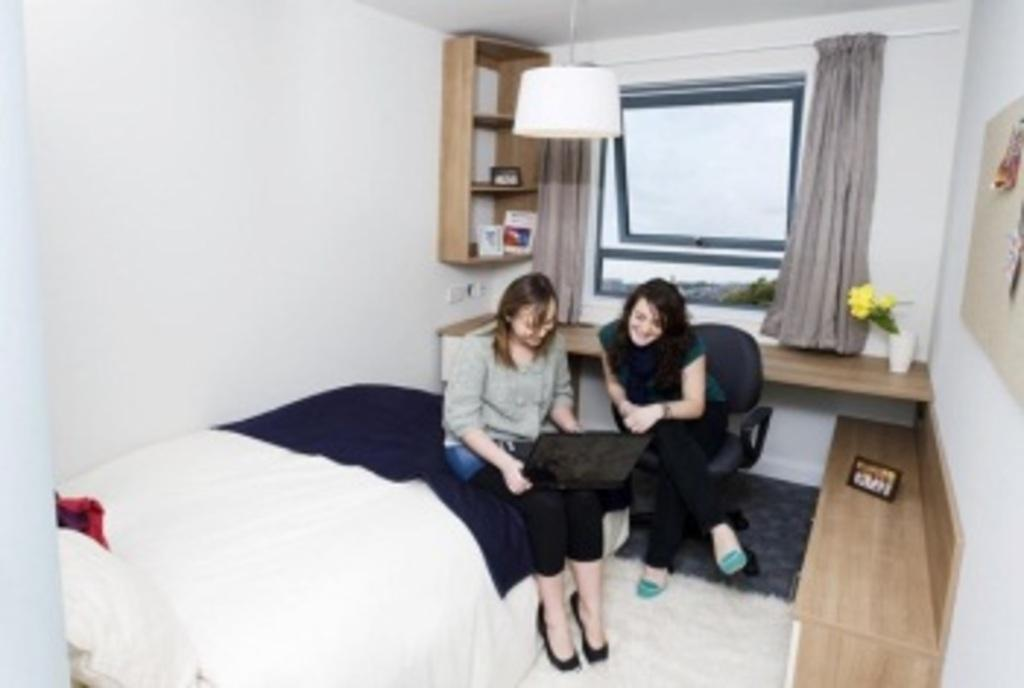How many people are present in the image? There are two persons sitting in the image. What can be seen in the background of the image? There is light, a bed, a blanket, a pillow, a photo frame, a flower vase, a curtain, and a window in the background of the image. What is the purpose of the blanket and pillow in the image? The blanket and pillow are on the bed, suggesting they are for sleeping or resting. What is the function of the photo frame and flower vase in the image? The photo frame and flower vase are likely for decoration or displaying personal items. What type of bike is visible in the image? There is no bike present in the image. What activity are the two persons engaged in during the image? The image does not provide enough information to determine the specific activity the two persons are engaged in. 